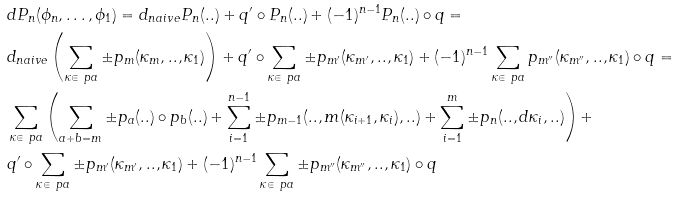<formula> <loc_0><loc_0><loc_500><loc_500>\ & d P _ { n } ( \phi _ { n } , \dots , \phi _ { 1 } ) = d _ { n a i v e } P _ { n } ( . . ) + q ^ { \prime } \circ P _ { n } ( . . ) + ( - 1 ) ^ { n - 1 } P _ { n } ( . . ) \circ q = \\ & d _ { n a i v e } \left ( \sum _ { \kappa \in \ p a } \pm p _ { m } ( \kappa _ { m } , . . , \kappa _ { 1 } ) \right ) + q ^ { \prime } \circ \sum _ { \kappa \in \ p a } \pm p _ { m ^ { \prime } } ( \kappa _ { m ^ { \prime } } , . . , \kappa _ { 1 } ) + ( - 1 ) ^ { n - 1 } \sum _ { \kappa \in \ p a } p _ { m ^ { \prime \prime } } ( \kappa _ { m ^ { \prime \prime } } , . . , \kappa _ { 1 } ) \circ q = \\ & \sum _ { \kappa \in \ p a } \left ( \sum _ { a + b = m } \pm p _ { a } ( . . ) \circ p _ { b } ( . . ) + \sum _ { i = 1 } ^ { n - 1 } \pm p _ { m - 1 } ( . . , m ( \kappa _ { i + 1 } , \kappa _ { i } ) , . . ) + \sum _ { i = 1 } ^ { m } \pm p _ { n } ( . . , d \kappa _ { i } , . . ) \right ) + \\ & q ^ { \prime } \circ \sum _ { \kappa \in \ p a } \pm p _ { m ^ { \prime } } ( \kappa _ { m ^ { \prime } } , . . , \kappa _ { 1 } ) + ( - 1 ) ^ { n - 1 } \sum _ { \kappa \in \ p a } \pm p _ { m ^ { \prime \prime } } ( \kappa _ { m ^ { \prime \prime } } , . . , \kappa _ { 1 } ) \circ q</formula> 